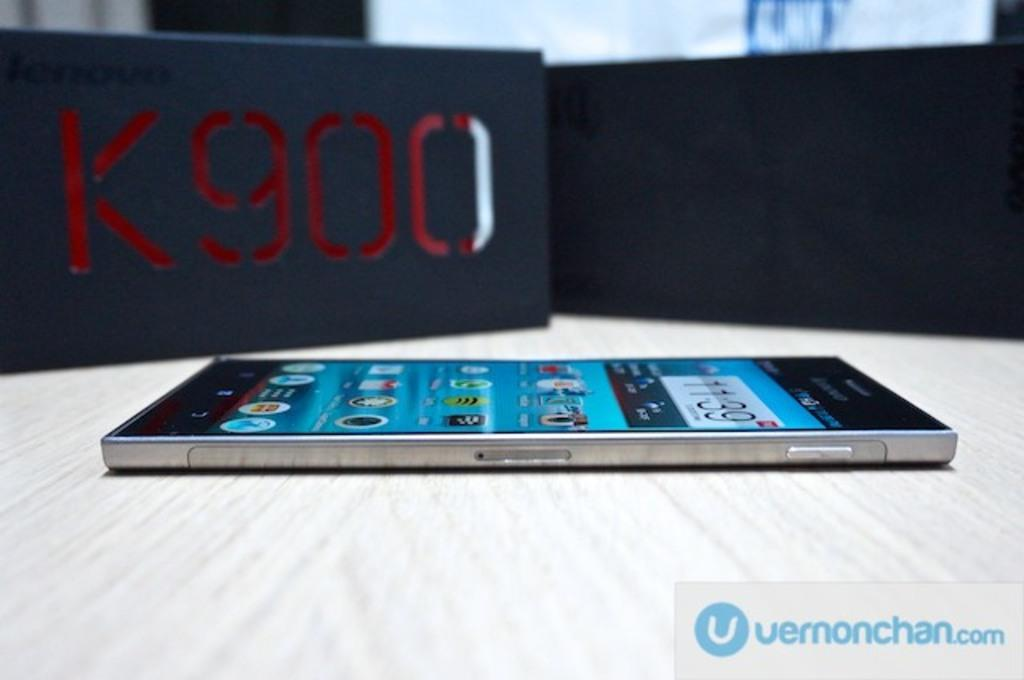<image>
Describe the image concisely. A smartphone is on a table with a tag showing the series of the phone which is K900 